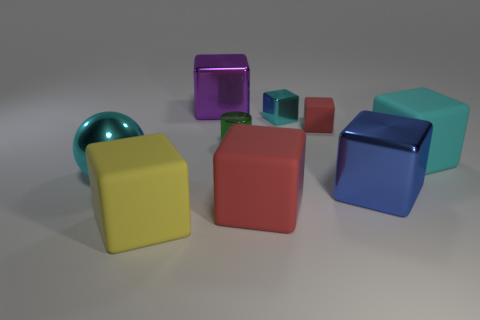Are any large cyan metal objects visible? yes 